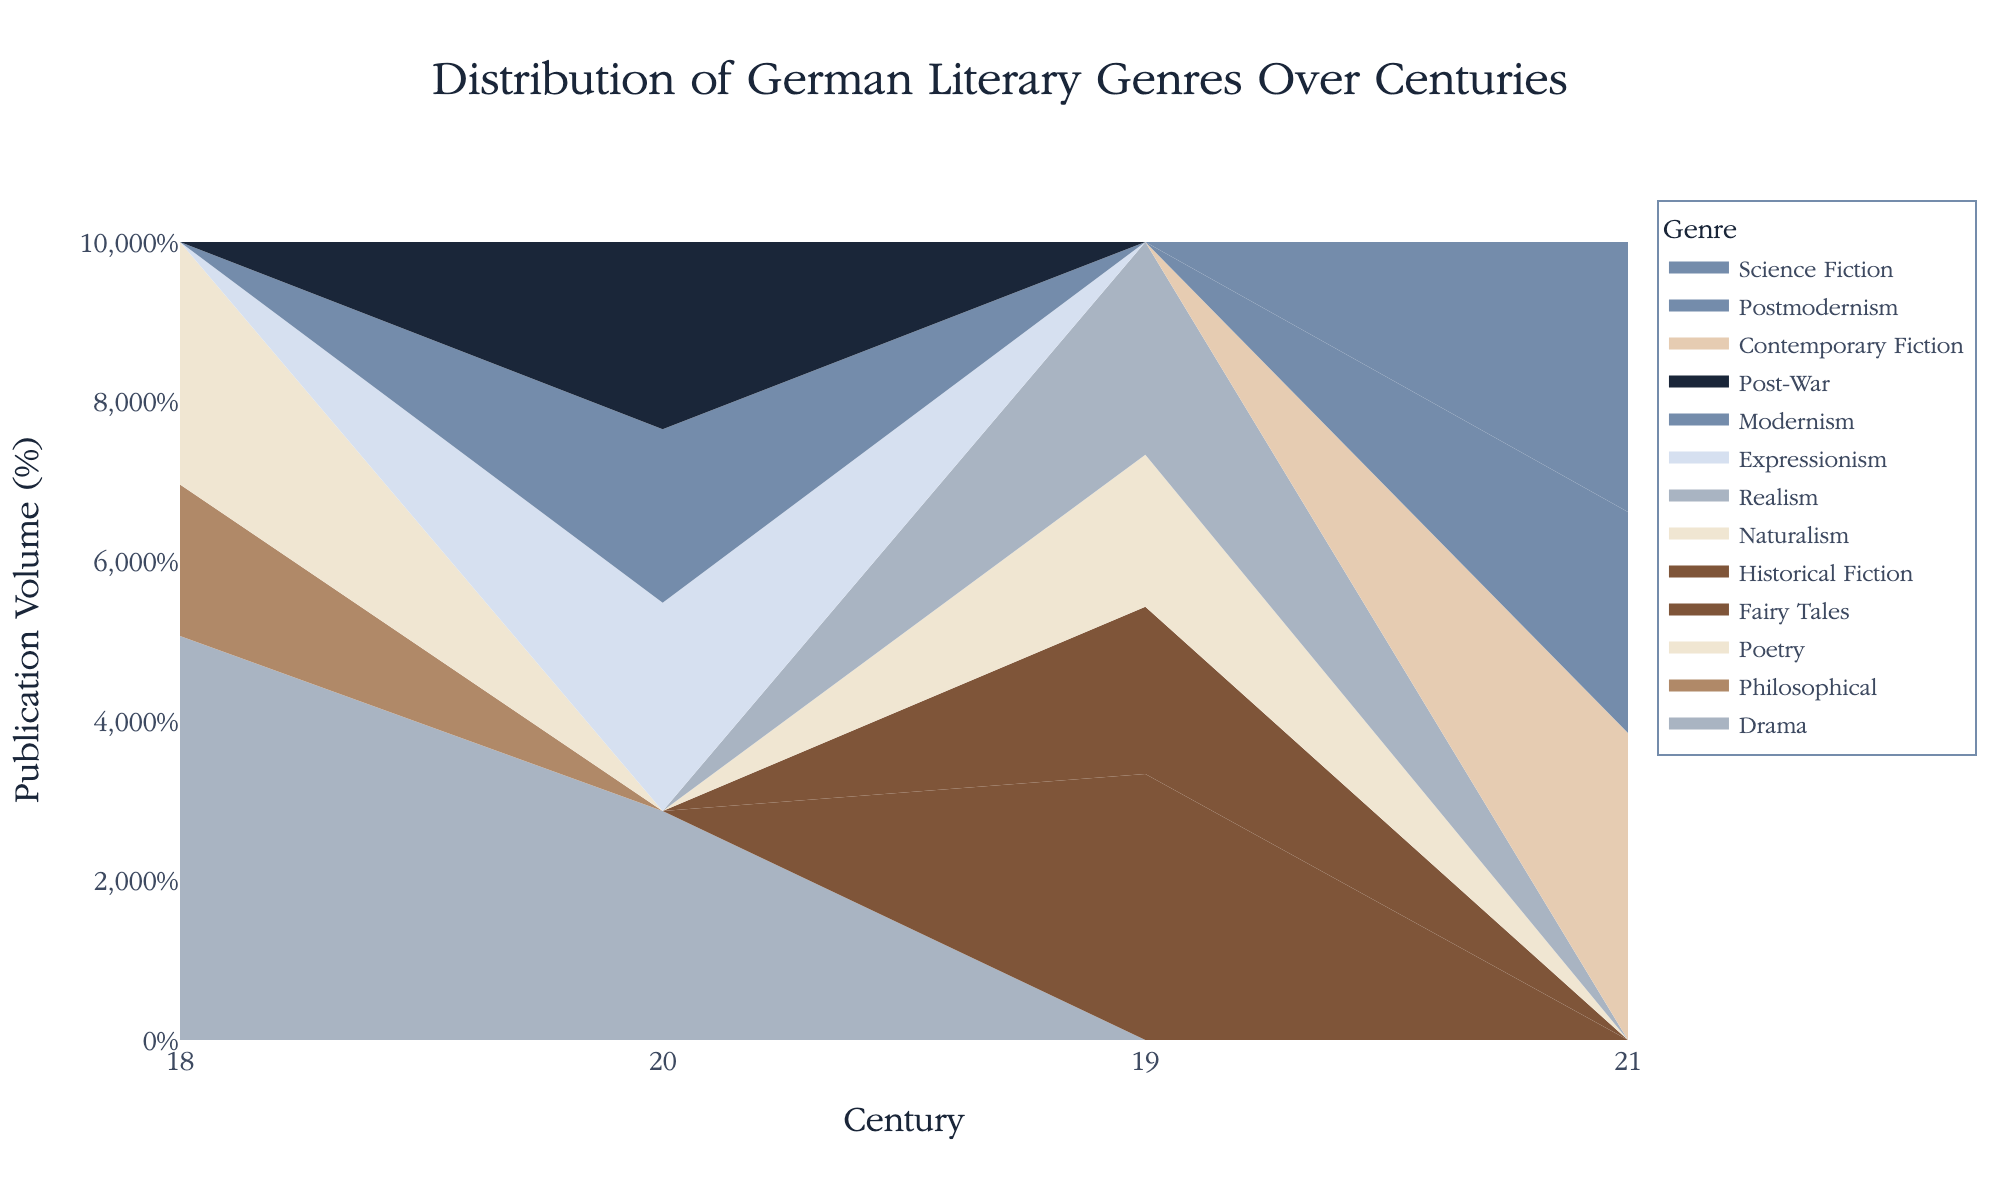What is the title of the graph? The title of the graph is usually displayed at the top of the figure. This graph's title helps identify the subject of the data presented.
Answer: Distribution of German Literary Genres Over Centuries Which century has the highest publication volume for the Drama genre? To find this, locate each century on the x-axis and check which has the thickest area (highest volume) in the stream graph specific to the Drama genre's color.
Answer: 20th century Who is the leading author in the Fairy Tales genre in the 19th century? To determine this, find the 19th century on the x-axis, look for the Fairy Tales stream, and hover over it to see the author information.
Answer: Jacob Grimm How does the publication volume of Science Fiction in the 21st century compare to that of Philosophical works in the 18th century? Identify the areas for Science Fiction in the 21st century and Philosophical works in the 18th century; compare the sizes visually.
Answer: Science Fiction is larger What is the combined publication volume of the Realism and Naturalism genres in the 19th century? Identify the Realism and Naturalism streams in the 19th century, add their volumes as seen on the graph.
Answer: 48 Which author has the highest publication volume in the 20th century? Locate each author’s publication volume in the 20th-century stream segments and identify the highest one.
Answer: Bertolt Brecht Which genre showed a notable increase in publication volume from the 18th to the 19th century? Compare the stream widths (volume) from the 18th century to the 19th century for each genre to identify any increases.
Answer: Fairy Tales How many unique genres are displayed in the graph? Count the distinct stream segments in the chart, each representing a different genre.
Answer: 11 What pattern do you observe in the Post-War genre's publication volume over centuries? Look at the Post-War stream area across centuries and describe the trend.
Answer: It appears only in the 20th century Who contributed the most to the Modernism genre, and in which century? Identify the Modernism stream and check the author name linked to the highest volume in the respective century.
Answer: Thomas Mann in the 20th century 